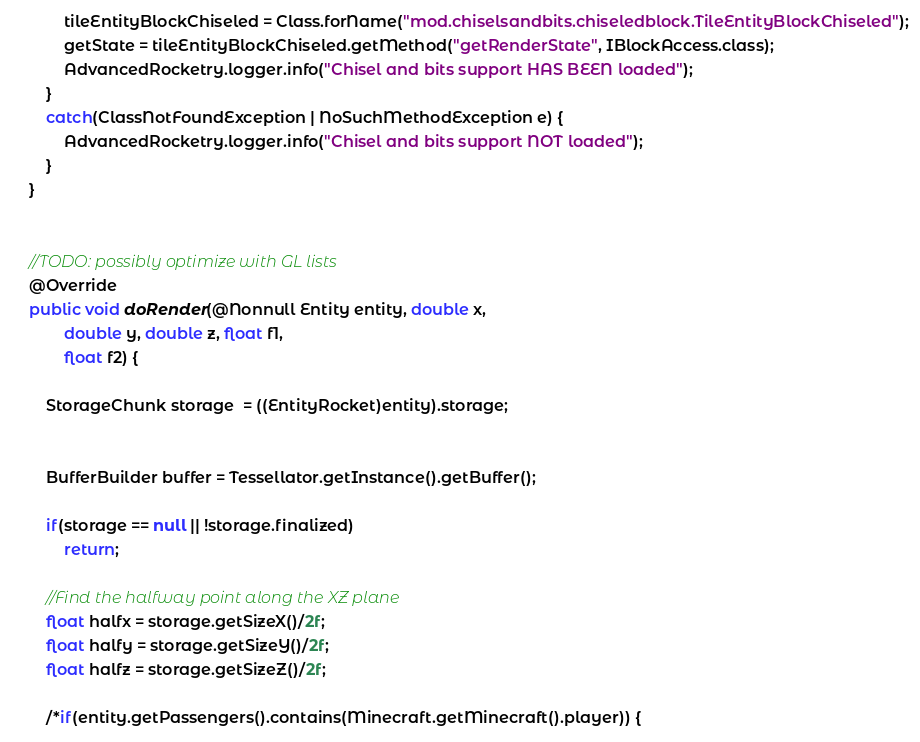<code> <loc_0><loc_0><loc_500><loc_500><_Java_>			tileEntityBlockChiseled = Class.forName("mod.chiselsandbits.chiseledblock.TileEntityBlockChiseled");
			getState = tileEntityBlockChiseled.getMethod("getRenderState", IBlockAccess.class);
			AdvancedRocketry.logger.info("Chisel and bits support HAS BEEN loaded");
		}
		catch(ClassNotFoundException | NoSuchMethodException e) {
			AdvancedRocketry.logger.info("Chisel and bits support NOT loaded");
		}
	}


	//TODO: possibly optimize with GL lists
	@Override
	public void doRender(@Nonnull Entity entity, double x,
			double y, double z, float f1,
			float f2) {

		StorageChunk storage  = ((EntityRocket)entity).storage;


		BufferBuilder buffer = Tessellator.getInstance().getBuffer();

		if(storage == null || !storage.finalized)
			return;
		
		//Find the halfway point along the XZ plane
		float halfx = storage.getSizeX()/2f;
		float halfy = storage.getSizeY()/2f;
		float halfz = storage.getSizeZ()/2f;

		/*if(entity.getPassengers().contains(Minecraft.getMinecraft().player)) {</code> 